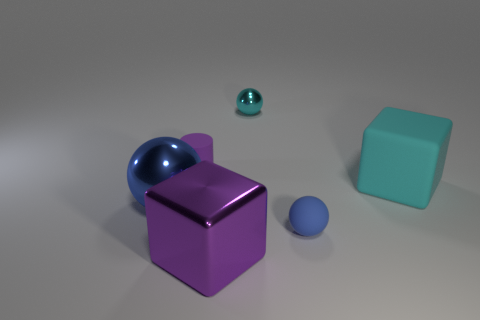Add 1 big spheres. How many objects exist? 7 Subtract all cubes. How many objects are left? 4 Add 1 brown matte things. How many brown matte things exist? 1 Subtract 1 purple blocks. How many objects are left? 5 Subtract all big green metal balls. Subtract all cyan spheres. How many objects are left? 5 Add 2 matte objects. How many matte objects are left? 5 